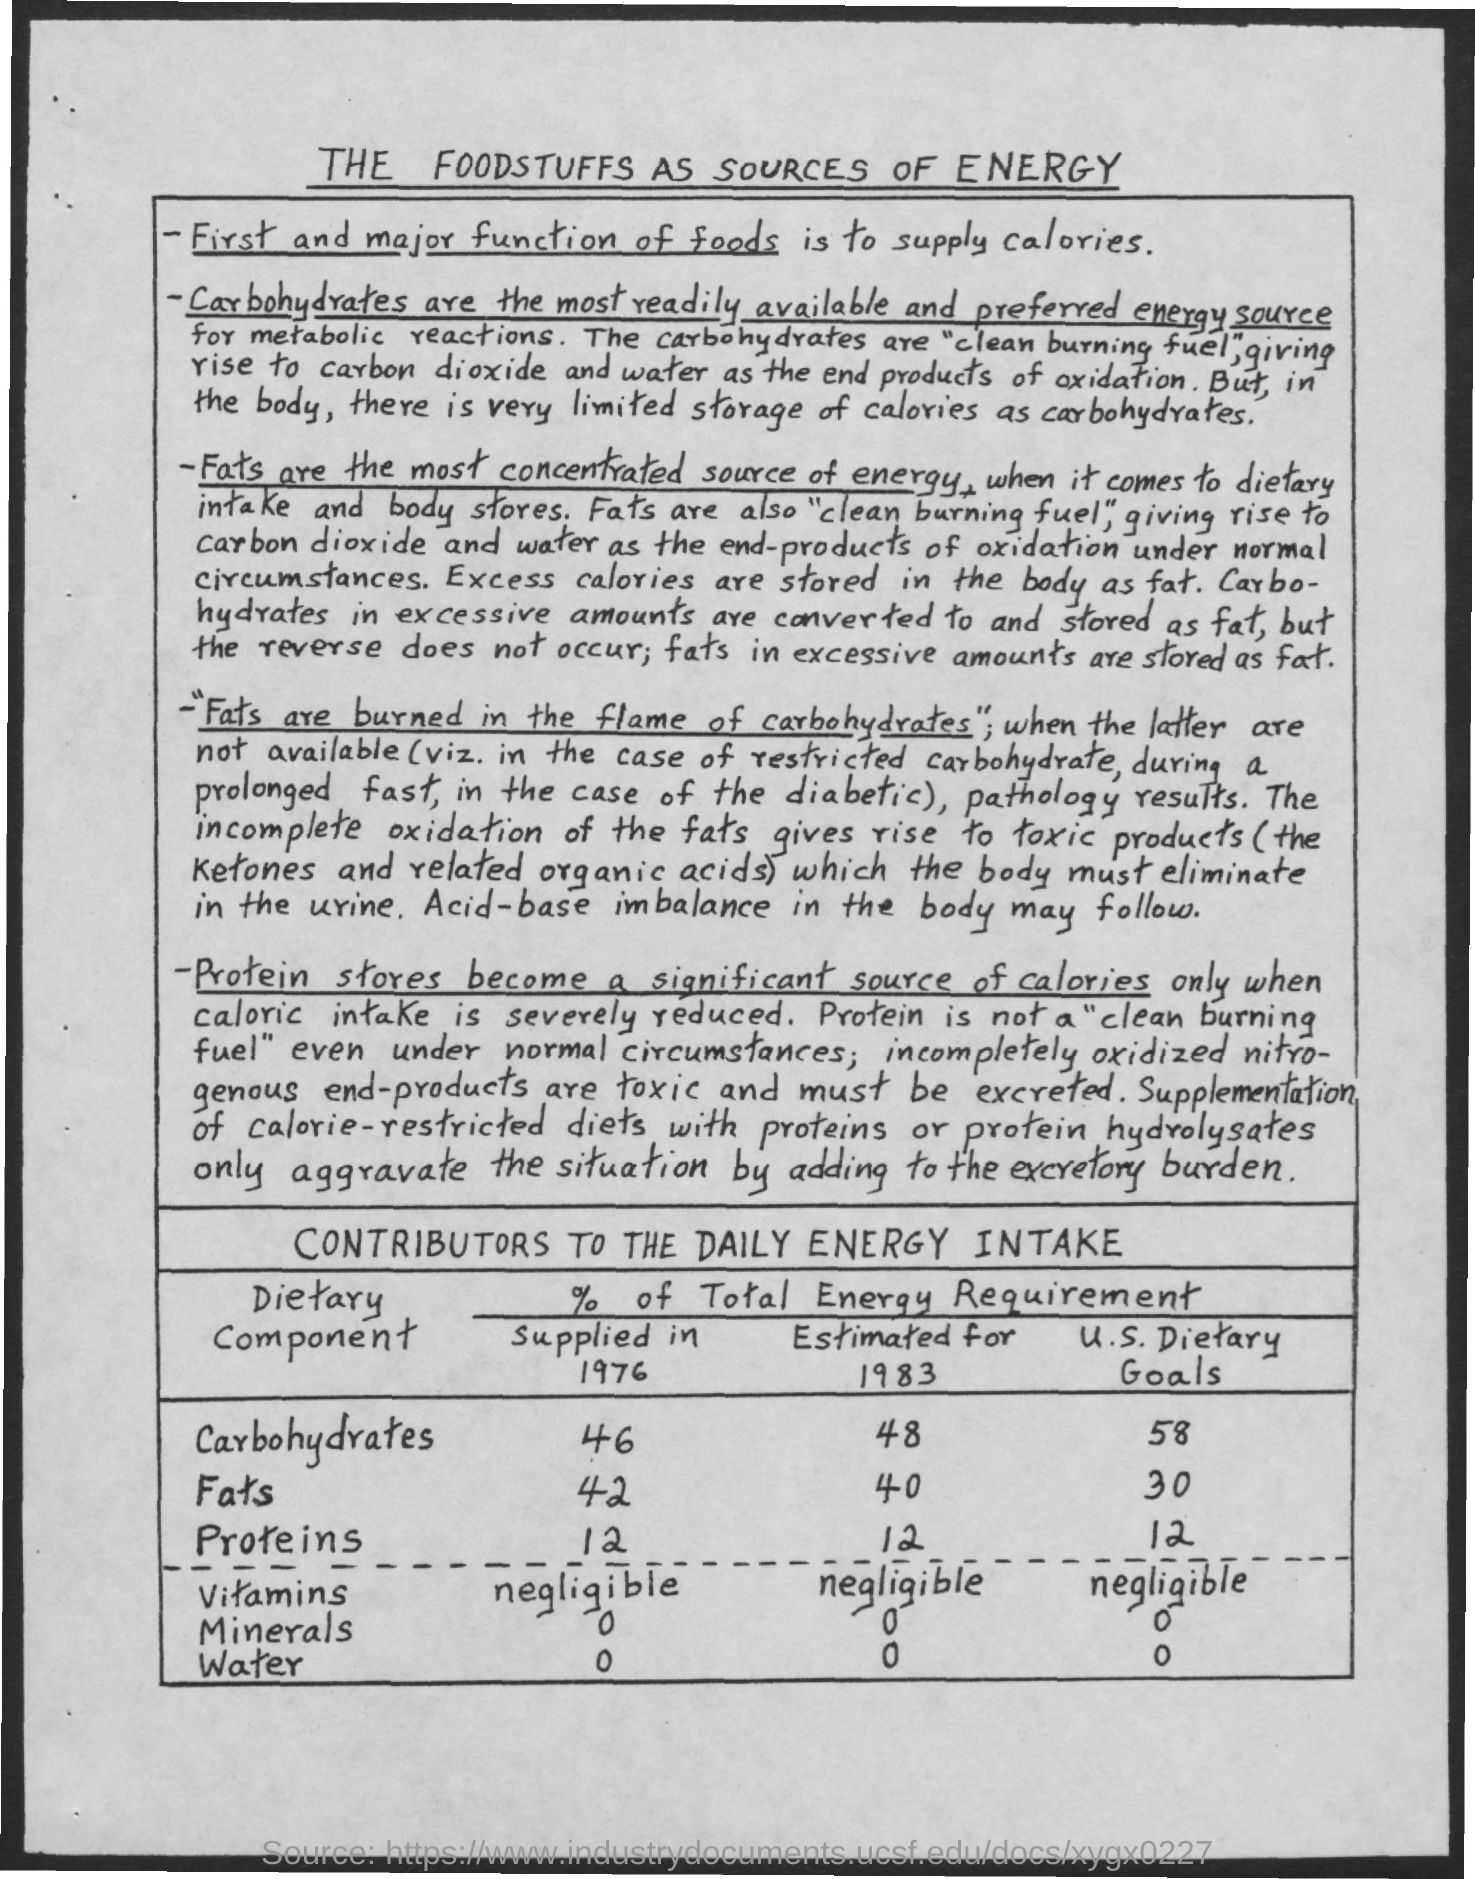What is Title of document?
Offer a very short reply. The Foodstuffs as Sources of Energy. What are most readily available and preferred energy source?
Give a very brief answer. Carbohydrates. What are the most concentrated source of energy?
Make the answer very short. Fats. What is % of fats supplied in 1976?
Provide a short and direct response. 42. 